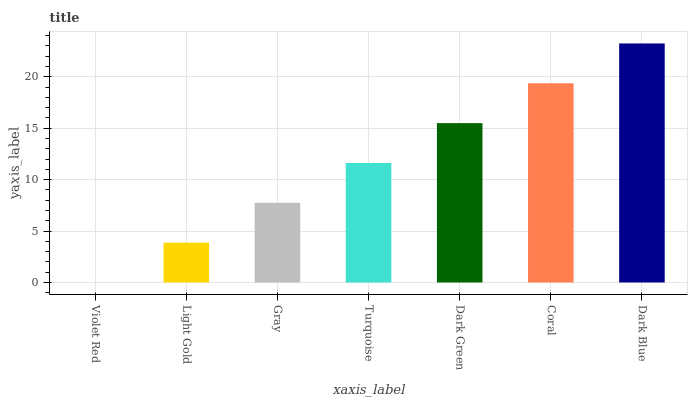Is Light Gold the minimum?
Answer yes or no. No. Is Light Gold the maximum?
Answer yes or no. No. Is Light Gold greater than Violet Red?
Answer yes or no. Yes. Is Violet Red less than Light Gold?
Answer yes or no. Yes. Is Violet Red greater than Light Gold?
Answer yes or no. No. Is Light Gold less than Violet Red?
Answer yes or no. No. Is Turquoise the high median?
Answer yes or no. Yes. Is Turquoise the low median?
Answer yes or no. Yes. Is Gray the high median?
Answer yes or no. No. Is Violet Red the low median?
Answer yes or no. No. 